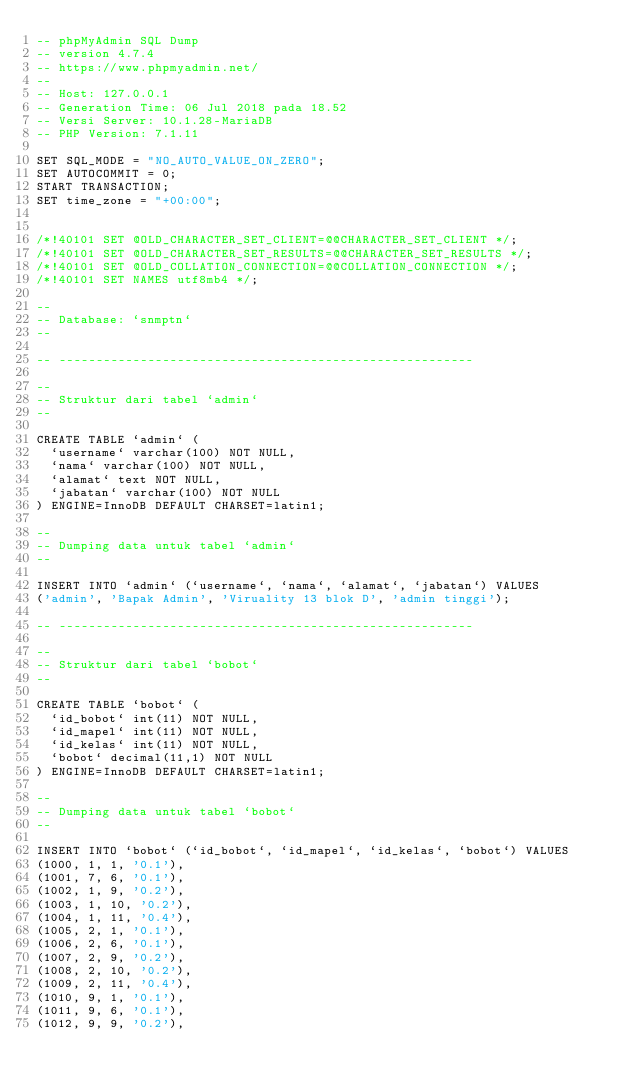<code> <loc_0><loc_0><loc_500><loc_500><_SQL_>-- phpMyAdmin SQL Dump
-- version 4.7.4
-- https://www.phpmyadmin.net/
--
-- Host: 127.0.0.1
-- Generation Time: 06 Jul 2018 pada 18.52
-- Versi Server: 10.1.28-MariaDB
-- PHP Version: 7.1.11

SET SQL_MODE = "NO_AUTO_VALUE_ON_ZERO";
SET AUTOCOMMIT = 0;
START TRANSACTION;
SET time_zone = "+00:00";


/*!40101 SET @OLD_CHARACTER_SET_CLIENT=@@CHARACTER_SET_CLIENT */;
/*!40101 SET @OLD_CHARACTER_SET_RESULTS=@@CHARACTER_SET_RESULTS */;
/*!40101 SET @OLD_COLLATION_CONNECTION=@@COLLATION_CONNECTION */;
/*!40101 SET NAMES utf8mb4 */;

--
-- Database: `snmptn`
--

-- --------------------------------------------------------

--
-- Struktur dari tabel `admin`
--

CREATE TABLE `admin` (
  `username` varchar(100) NOT NULL,
  `nama` varchar(100) NOT NULL,
  `alamat` text NOT NULL,
  `jabatan` varchar(100) NOT NULL
) ENGINE=InnoDB DEFAULT CHARSET=latin1;

--
-- Dumping data untuk tabel `admin`
--

INSERT INTO `admin` (`username`, `nama`, `alamat`, `jabatan`) VALUES
('admin', 'Bapak Admin', 'Viruality 13 blok D', 'admin tinggi');

-- --------------------------------------------------------

--
-- Struktur dari tabel `bobot`
--

CREATE TABLE `bobot` (
  `id_bobot` int(11) NOT NULL,
  `id_mapel` int(11) NOT NULL,
  `id_kelas` int(11) NOT NULL,
  `bobot` decimal(11,1) NOT NULL
) ENGINE=InnoDB DEFAULT CHARSET=latin1;

--
-- Dumping data untuk tabel `bobot`
--

INSERT INTO `bobot` (`id_bobot`, `id_mapel`, `id_kelas`, `bobot`) VALUES
(1000, 1, 1, '0.1'),
(1001, 7, 6, '0.1'),
(1002, 1, 9, '0.2'),
(1003, 1, 10, '0.2'),
(1004, 1, 11, '0.4'),
(1005, 2, 1, '0.1'),
(1006, 2, 6, '0.1'),
(1007, 2, 9, '0.2'),
(1008, 2, 10, '0.2'),
(1009, 2, 11, '0.4'),
(1010, 9, 1, '0.1'),
(1011, 9, 6, '0.1'),
(1012, 9, 9, '0.2'),</code> 